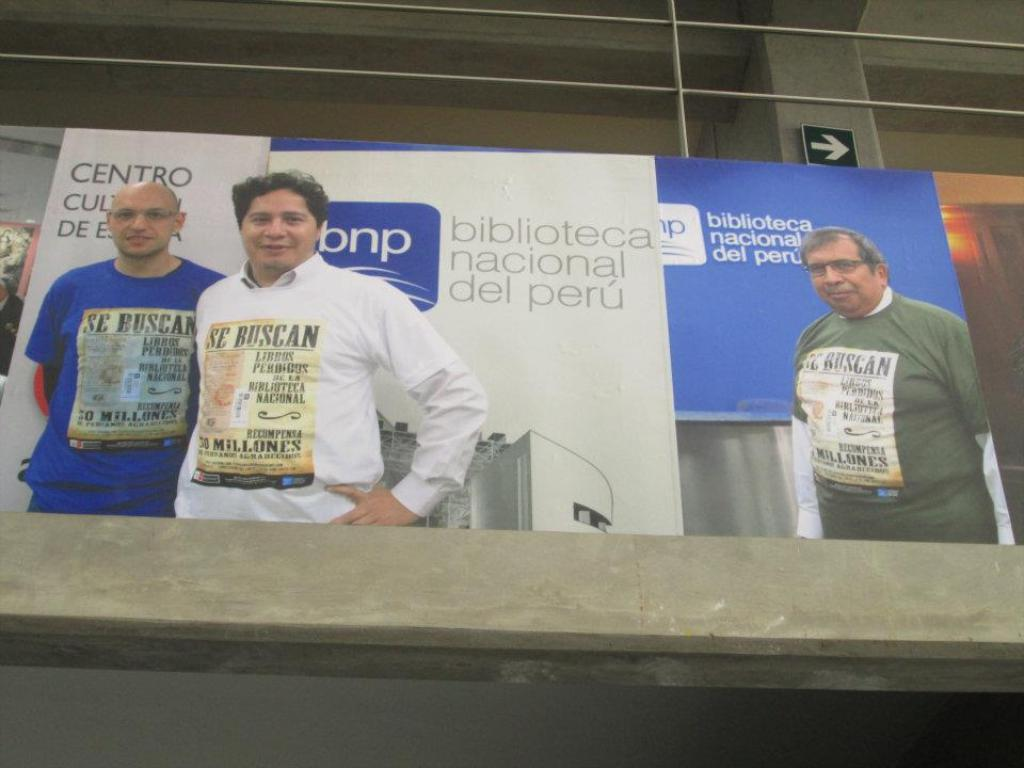What is on the building in the image? There is a big poster on a building in the image. What can be seen on the poster? The poster contains images of people. Is there any text or additional information on the poster? Yes, there is a note on the poster. Can you see the parent of the people in the image? There is no parent visible in the image; the poster contains images of people, but no indication of their parents. 